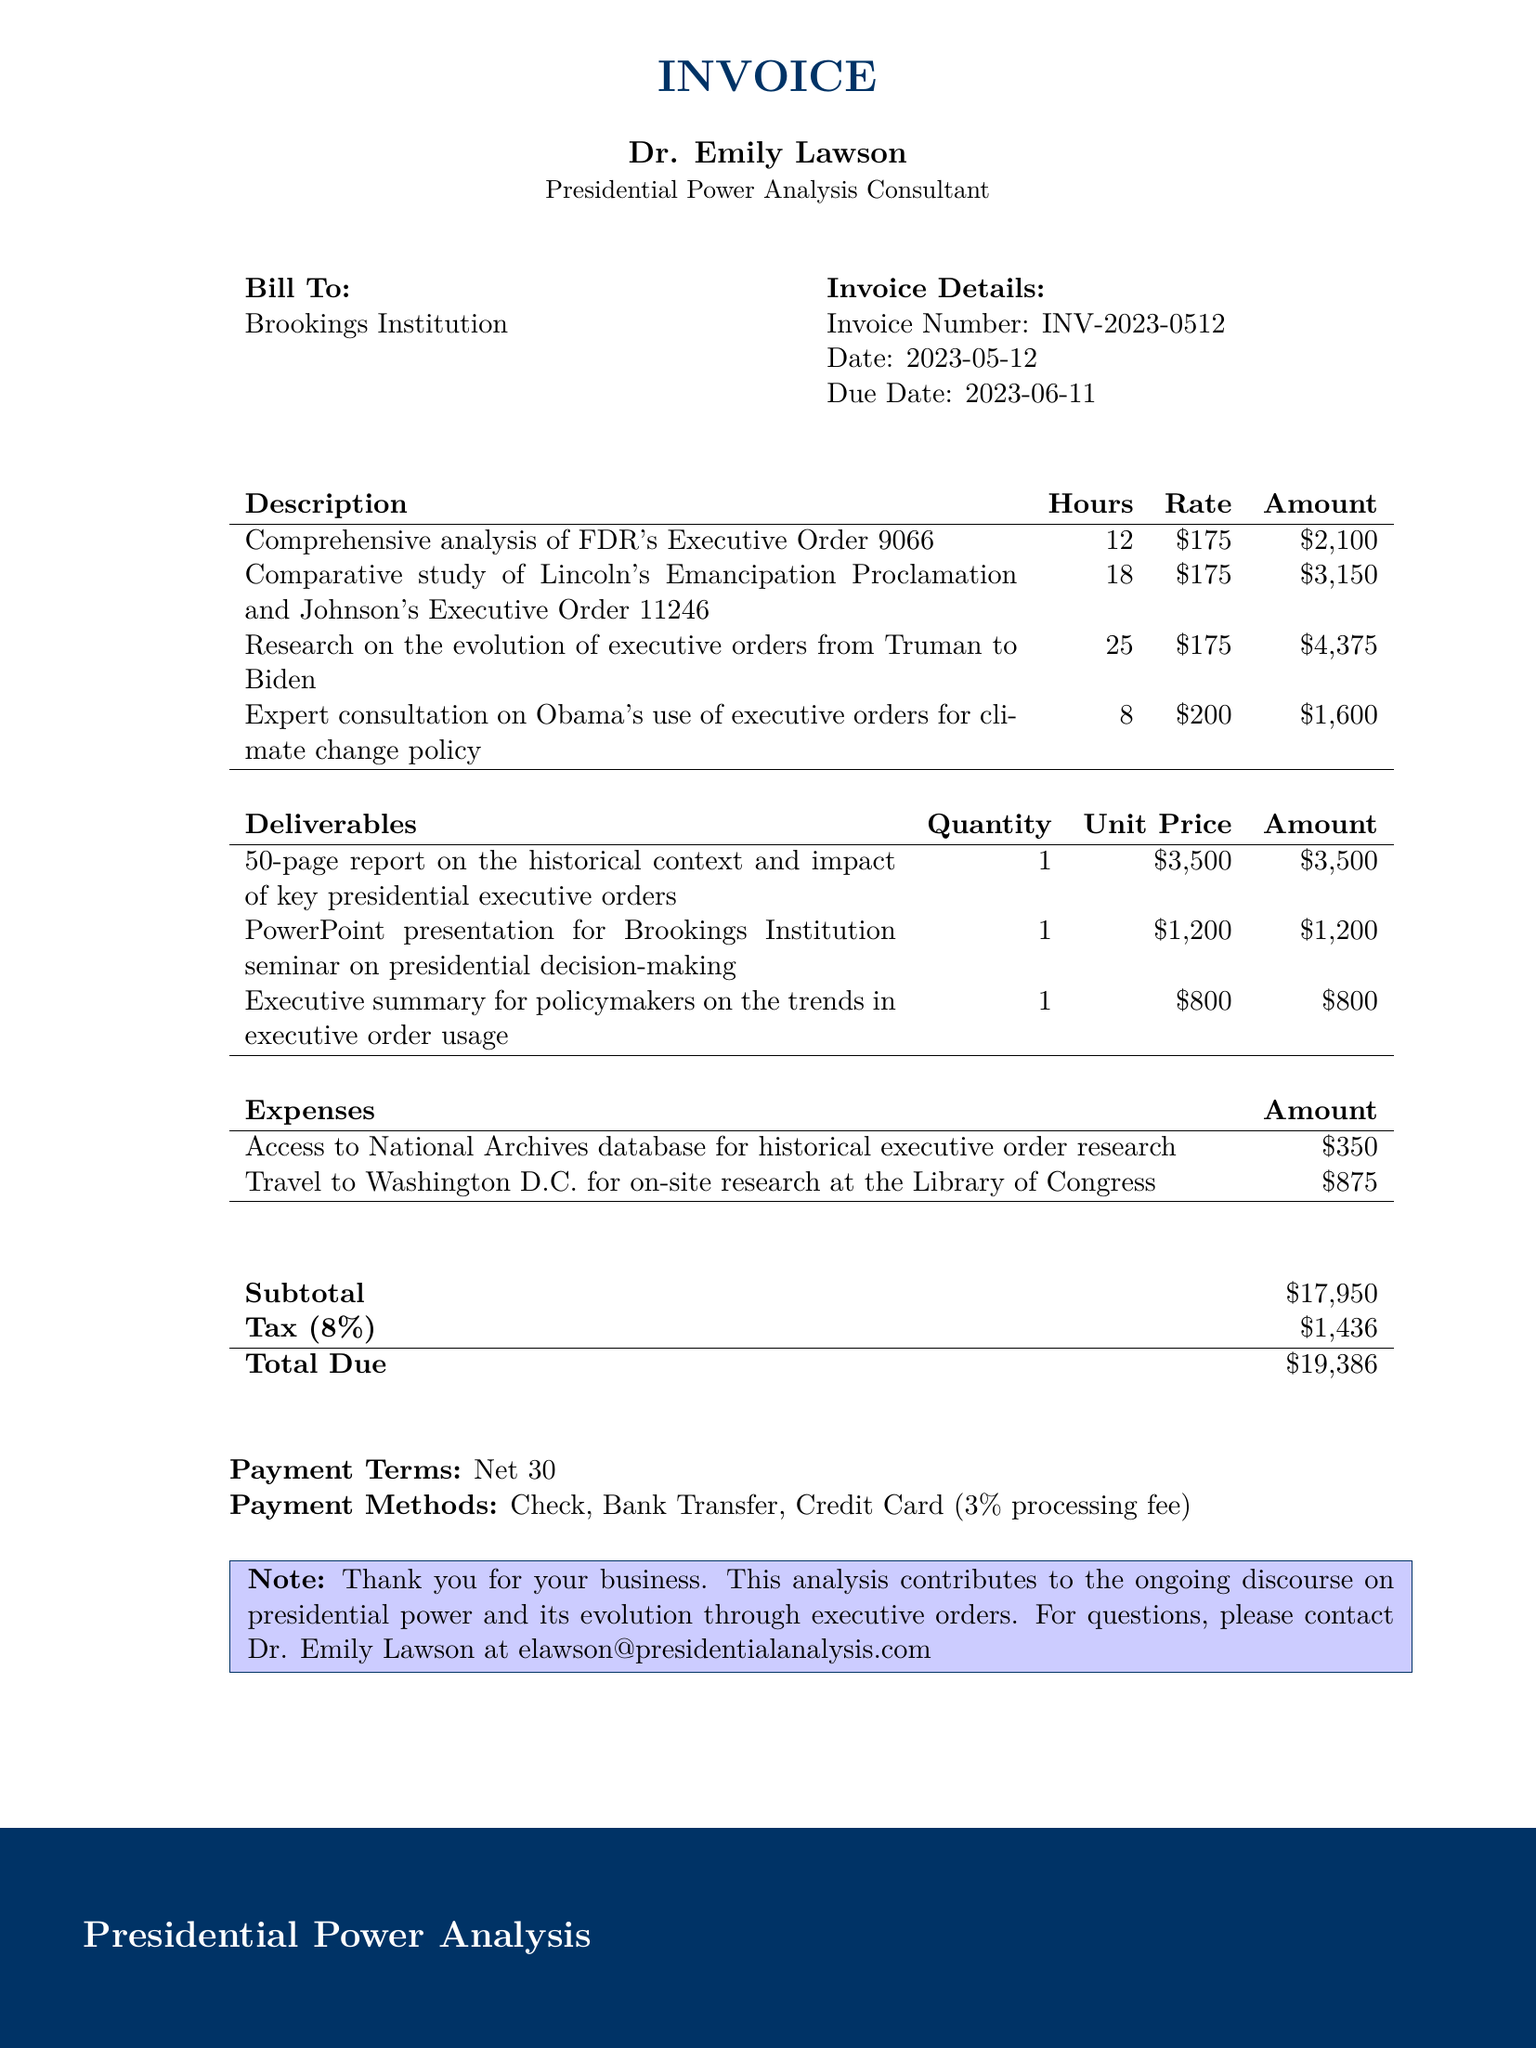What is the invoice number? The invoice number is specifically stated in the document as a unique identifier for the transaction.
Answer: INV-2023-0512 Who is the client? The client is specified as the organization that received the consulting services outlined in the document.
Answer: Brookings Institution How many hours were spent on the research from Truman to Biden? This includes the hours dedicated to a specific task, and is clearly listed in the services section of the document.
Answer: 25 What is the total amount due? The total amount due is provided as the final figure to be paid by the client, after calculations of subtotal, tax, and expenses.
Answer: 19386 What is the rate charged for expert consultation on Obama's climate change policy? This detail specifies the payment structure for each hour of consultation provided in the document.
Answer: 200 What is the subtotal of services provided? The subtotal is calculated by summing the amounts of all services rendered, and is explicitly listed.
Answer: 11225 What deliverable is provided for the seminar on presidential decision-making? This deliverable is specific in the document, indicating what output was given for the event mentioned.
Answer: PowerPoint presentation What is the tax rate applied to the invoice? The document clearly states the tax rate applied to the subtotal, affecting the total amount due.
Answer: 8% How many expenses are listed in the invoice? This information requires counting the distinct expense items mentioned in the document.
Answer: 2 